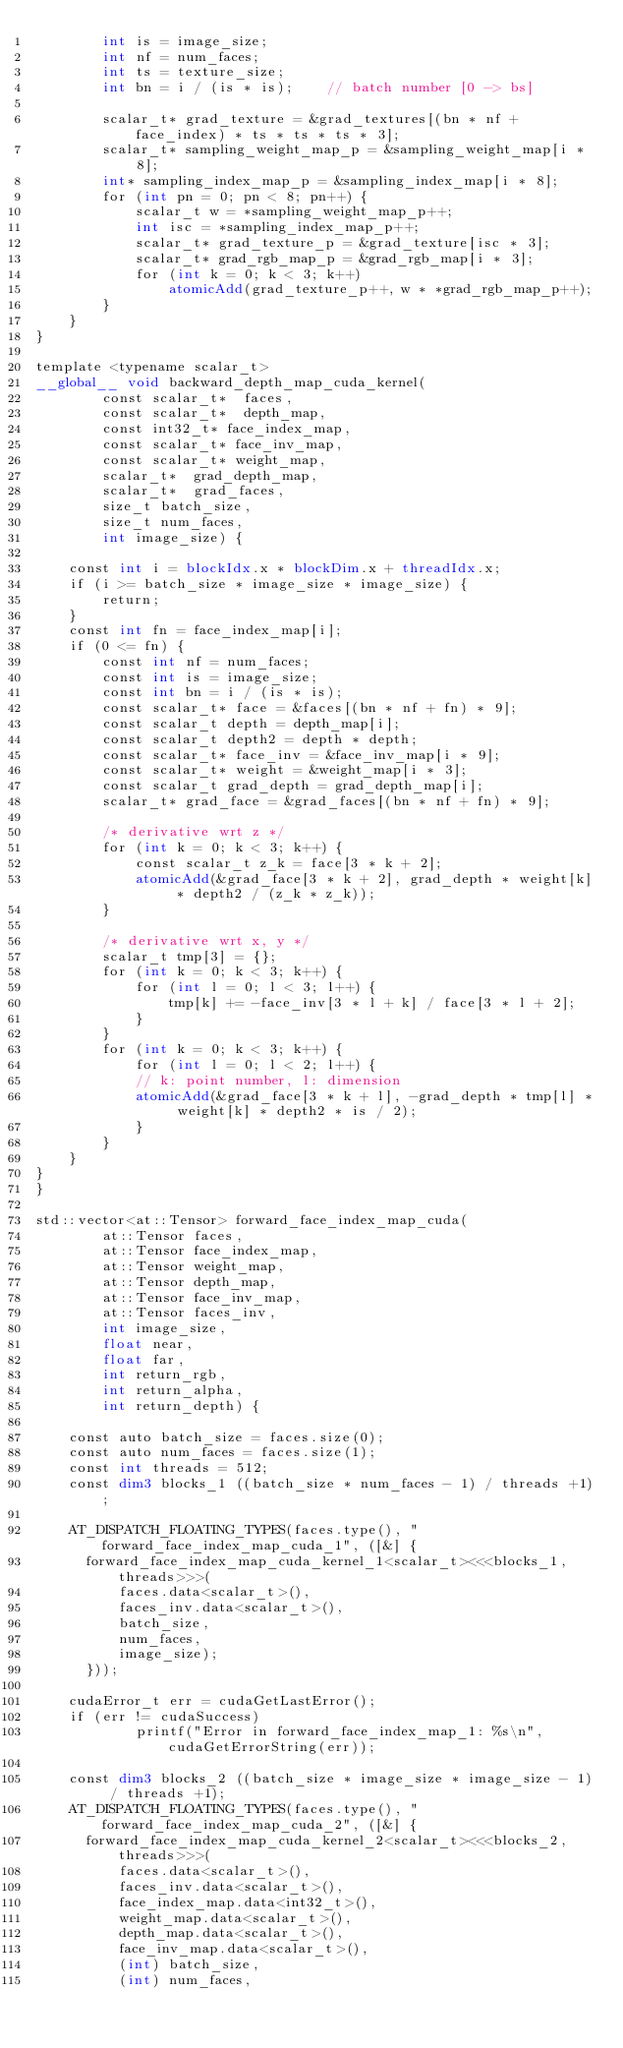<code> <loc_0><loc_0><loc_500><loc_500><_Cuda_>        int is = image_size;
        int nf = num_faces;
        int ts = texture_size;
        int bn = i / (is * is);    // batch number [0 -> bs]
    
        scalar_t* grad_texture = &grad_textures[(bn * nf + face_index) * ts * ts * ts * 3];
        scalar_t* sampling_weight_map_p = &sampling_weight_map[i * 8];
        int* sampling_index_map_p = &sampling_index_map[i * 8];
        for (int pn = 0; pn < 8; pn++) {
            scalar_t w = *sampling_weight_map_p++;
            int isc = *sampling_index_map_p++;
            scalar_t* grad_texture_p = &grad_texture[isc * 3];
            scalar_t* grad_rgb_map_p = &grad_rgb_map[i * 3];
            for (int k = 0; k < 3; k++)
                atomicAdd(grad_texture_p++, w * *grad_rgb_map_p++);
        }
    }
}

template <typename scalar_t>
__global__ void backward_depth_map_cuda_kernel(
        const scalar_t*  faces,
        const scalar_t*  depth_map,
        const int32_t* face_index_map,
        const scalar_t* face_inv_map,
        const scalar_t* weight_map,
        scalar_t*  grad_depth_map,
        scalar_t*  grad_faces,
        size_t batch_size,
        size_t num_faces,
        int image_size) {
    
    const int i = blockIdx.x * blockDim.x + threadIdx.x;
    if (i >= batch_size * image_size * image_size) {
        return;
    }
    const int fn = face_index_map[i];
    if (0 <= fn) {
        const int nf = num_faces;
        const int is = image_size;
        const int bn = i / (is * is);
        const scalar_t* face = &faces[(bn * nf + fn) * 9];
        const scalar_t depth = depth_map[i];
        const scalar_t depth2 = depth * depth;
        const scalar_t* face_inv = &face_inv_map[i * 9];
        const scalar_t* weight = &weight_map[i * 3];
        const scalar_t grad_depth = grad_depth_map[i];
        scalar_t* grad_face = &grad_faces[(bn * nf + fn) * 9];
    
        /* derivative wrt z */
        for (int k = 0; k < 3; k++) {
            const scalar_t z_k = face[3 * k + 2];
            atomicAdd(&grad_face[3 * k + 2], grad_depth * weight[k] * depth2 / (z_k * z_k));
        }
    
        /* derivative wrt x, y */
        scalar_t tmp[3] = {};
        for (int k = 0; k < 3; k++) {
            for (int l = 0; l < 3; l++) {
                tmp[k] += -face_inv[3 * l + k] / face[3 * l + 2];
            }
        }
        for (int k = 0; k < 3; k++) {
            for (int l = 0; l < 2; l++) {
            // k: point number, l: dimension
            atomicAdd(&grad_face[3 * k + l], -grad_depth * tmp[l] * weight[k] * depth2 * is / 2);
            }
        }
    }
}
}

std::vector<at::Tensor> forward_face_index_map_cuda(
        at::Tensor faces,
        at::Tensor face_index_map,
        at::Tensor weight_map,
        at::Tensor depth_map,
        at::Tensor face_inv_map,
        at::Tensor faces_inv,
        int image_size,
        float near,
        float far,
        int return_rgb,
        int return_alpha,
        int return_depth) {

    const auto batch_size = faces.size(0);
    const auto num_faces = faces.size(1);
    const int threads = 512;
    const dim3 blocks_1 ((batch_size * num_faces - 1) / threads +1);

    AT_DISPATCH_FLOATING_TYPES(faces.type(), "forward_face_index_map_cuda_1", ([&] {
      forward_face_index_map_cuda_kernel_1<scalar_t><<<blocks_1, threads>>>(
          faces.data<scalar_t>(),
          faces_inv.data<scalar_t>(),
          batch_size,
          num_faces,
          image_size);
      }));

    cudaError_t err = cudaGetLastError();
    if (err != cudaSuccess) 
            printf("Error in forward_face_index_map_1: %s\n", cudaGetErrorString(err));

    const dim3 blocks_2 ((batch_size * image_size * image_size - 1) / threads +1);
    AT_DISPATCH_FLOATING_TYPES(faces.type(), "forward_face_index_map_cuda_2", ([&] {
      forward_face_index_map_cuda_kernel_2<scalar_t><<<blocks_2, threads>>>(
          faces.data<scalar_t>(),
          faces_inv.data<scalar_t>(),
          face_index_map.data<int32_t>(),
          weight_map.data<scalar_t>(),
          depth_map.data<scalar_t>(),
          face_inv_map.data<scalar_t>(),
          (int) batch_size,
          (int) num_faces,</code> 